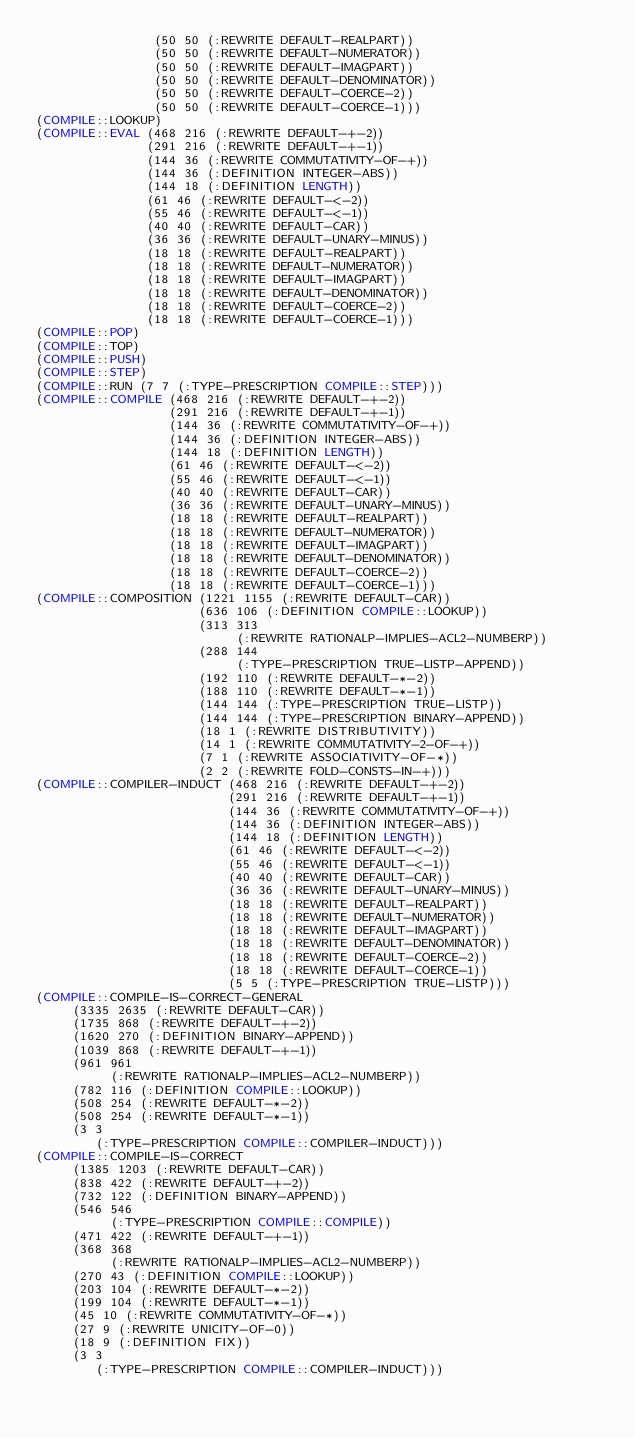<code> <loc_0><loc_0><loc_500><loc_500><_Lisp_>                (50 50 (:REWRITE DEFAULT-REALPART))
                (50 50 (:REWRITE DEFAULT-NUMERATOR))
                (50 50 (:REWRITE DEFAULT-IMAGPART))
                (50 50 (:REWRITE DEFAULT-DENOMINATOR))
                (50 50 (:REWRITE DEFAULT-COERCE-2))
                (50 50 (:REWRITE DEFAULT-COERCE-1)))
(COMPILE::LOOKUP)
(COMPILE::EVAL (468 216 (:REWRITE DEFAULT-+-2))
               (291 216 (:REWRITE DEFAULT-+-1))
               (144 36 (:REWRITE COMMUTATIVITY-OF-+))
               (144 36 (:DEFINITION INTEGER-ABS))
               (144 18 (:DEFINITION LENGTH))
               (61 46 (:REWRITE DEFAULT-<-2))
               (55 46 (:REWRITE DEFAULT-<-1))
               (40 40 (:REWRITE DEFAULT-CAR))
               (36 36 (:REWRITE DEFAULT-UNARY-MINUS))
               (18 18 (:REWRITE DEFAULT-REALPART))
               (18 18 (:REWRITE DEFAULT-NUMERATOR))
               (18 18 (:REWRITE DEFAULT-IMAGPART))
               (18 18 (:REWRITE DEFAULT-DENOMINATOR))
               (18 18 (:REWRITE DEFAULT-COERCE-2))
               (18 18 (:REWRITE DEFAULT-COERCE-1)))
(COMPILE::POP)
(COMPILE::TOP)
(COMPILE::PUSH)
(COMPILE::STEP)
(COMPILE::RUN (7 7 (:TYPE-PRESCRIPTION COMPILE::STEP)))
(COMPILE::COMPILE (468 216 (:REWRITE DEFAULT-+-2))
                  (291 216 (:REWRITE DEFAULT-+-1))
                  (144 36 (:REWRITE COMMUTATIVITY-OF-+))
                  (144 36 (:DEFINITION INTEGER-ABS))
                  (144 18 (:DEFINITION LENGTH))
                  (61 46 (:REWRITE DEFAULT-<-2))
                  (55 46 (:REWRITE DEFAULT-<-1))
                  (40 40 (:REWRITE DEFAULT-CAR))
                  (36 36 (:REWRITE DEFAULT-UNARY-MINUS))
                  (18 18 (:REWRITE DEFAULT-REALPART))
                  (18 18 (:REWRITE DEFAULT-NUMERATOR))
                  (18 18 (:REWRITE DEFAULT-IMAGPART))
                  (18 18 (:REWRITE DEFAULT-DENOMINATOR))
                  (18 18 (:REWRITE DEFAULT-COERCE-2))
                  (18 18 (:REWRITE DEFAULT-COERCE-1)))
(COMPILE::COMPOSITION (1221 1155 (:REWRITE DEFAULT-CAR))
                      (636 106 (:DEFINITION COMPILE::LOOKUP))
                      (313 313
                           (:REWRITE RATIONALP-IMPLIES-ACL2-NUMBERP))
                      (288 144
                           (:TYPE-PRESCRIPTION TRUE-LISTP-APPEND))
                      (192 110 (:REWRITE DEFAULT-*-2))
                      (188 110 (:REWRITE DEFAULT-*-1))
                      (144 144 (:TYPE-PRESCRIPTION TRUE-LISTP))
                      (144 144 (:TYPE-PRESCRIPTION BINARY-APPEND))
                      (18 1 (:REWRITE DISTRIBUTIVITY))
                      (14 1 (:REWRITE COMMUTATIVITY-2-OF-+))
                      (7 1 (:REWRITE ASSOCIATIVITY-OF-*))
                      (2 2 (:REWRITE FOLD-CONSTS-IN-+)))
(COMPILE::COMPILER-INDUCT (468 216 (:REWRITE DEFAULT-+-2))
                          (291 216 (:REWRITE DEFAULT-+-1))
                          (144 36 (:REWRITE COMMUTATIVITY-OF-+))
                          (144 36 (:DEFINITION INTEGER-ABS))
                          (144 18 (:DEFINITION LENGTH))
                          (61 46 (:REWRITE DEFAULT-<-2))
                          (55 46 (:REWRITE DEFAULT-<-1))
                          (40 40 (:REWRITE DEFAULT-CAR))
                          (36 36 (:REWRITE DEFAULT-UNARY-MINUS))
                          (18 18 (:REWRITE DEFAULT-REALPART))
                          (18 18 (:REWRITE DEFAULT-NUMERATOR))
                          (18 18 (:REWRITE DEFAULT-IMAGPART))
                          (18 18 (:REWRITE DEFAULT-DENOMINATOR))
                          (18 18 (:REWRITE DEFAULT-COERCE-2))
                          (18 18 (:REWRITE DEFAULT-COERCE-1))
                          (5 5 (:TYPE-PRESCRIPTION TRUE-LISTP)))
(COMPILE::COMPILE-IS-CORRECT-GENERAL
     (3335 2635 (:REWRITE DEFAULT-CAR))
     (1735 868 (:REWRITE DEFAULT-+-2))
     (1620 270 (:DEFINITION BINARY-APPEND))
     (1039 868 (:REWRITE DEFAULT-+-1))
     (961 961
          (:REWRITE RATIONALP-IMPLIES-ACL2-NUMBERP))
     (782 116 (:DEFINITION COMPILE::LOOKUP))
     (508 254 (:REWRITE DEFAULT-*-2))
     (508 254 (:REWRITE DEFAULT-*-1))
     (3 3
        (:TYPE-PRESCRIPTION COMPILE::COMPILER-INDUCT)))
(COMPILE::COMPILE-IS-CORRECT
     (1385 1203 (:REWRITE DEFAULT-CAR))
     (838 422 (:REWRITE DEFAULT-+-2))
     (732 122 (:DEFINITION BINARY-APPEND))
     (546 546
          (:TYPE-PRESCRIPTION COMPILE::COMPILE))
     (471 422 (:REWRITE DEFAULT-+-1))
     (368 368
          (:REWRITE RATIONALP-IMPLIES-ACL2-NUMBERP))
     (270 43 (:DEFINITION COMPILE::LOOKUP))
     (203 104 (:REWRITE DEFAULT-*-2))
     (199 104 (:REWRITE DEFAULT-*-1))
     (45 10 (:REWRITE COMMUTATIVITY-OF-*))
     (27 9 (:REWRITE UNICITY-OF-0))
     (18 9 (:DEFINITION FIX))
     (3 3
        (:TYPE-PRESCRIPTION COMPILE::COMPILER-INDUCT)))
</code> 